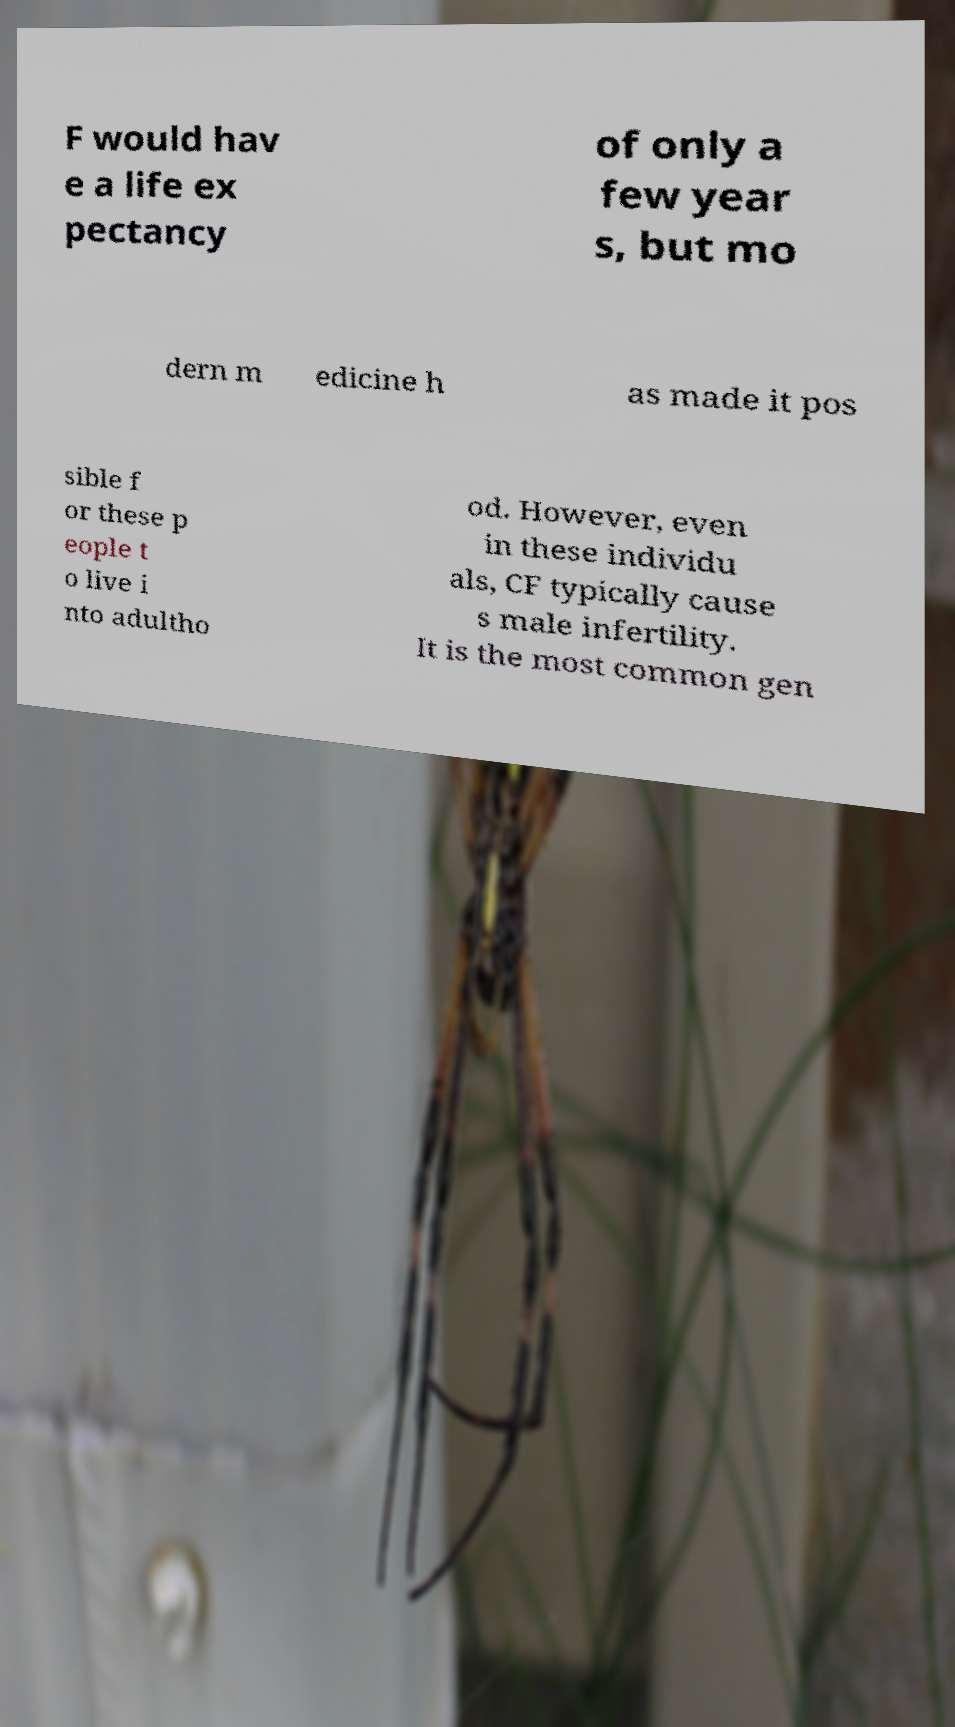Could you assist in decoding the text presented in this image and type it out clearly? F would hav e a life ex pectancy of only a few year s, but mo dern m edicine h as made it pos sible f or these p eople t o live i nto adultho od. However, even in these individu als, CF typically cause s male infertility. It is the most common gen 